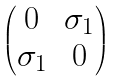<formula> <loc_0><loc_0><loc_500><loc_500>\begin{pmatrix} 0 & \sigma _ { 1 } \\ \sigma _ { 1 } & 0 \end{pmatrix}</formula> 